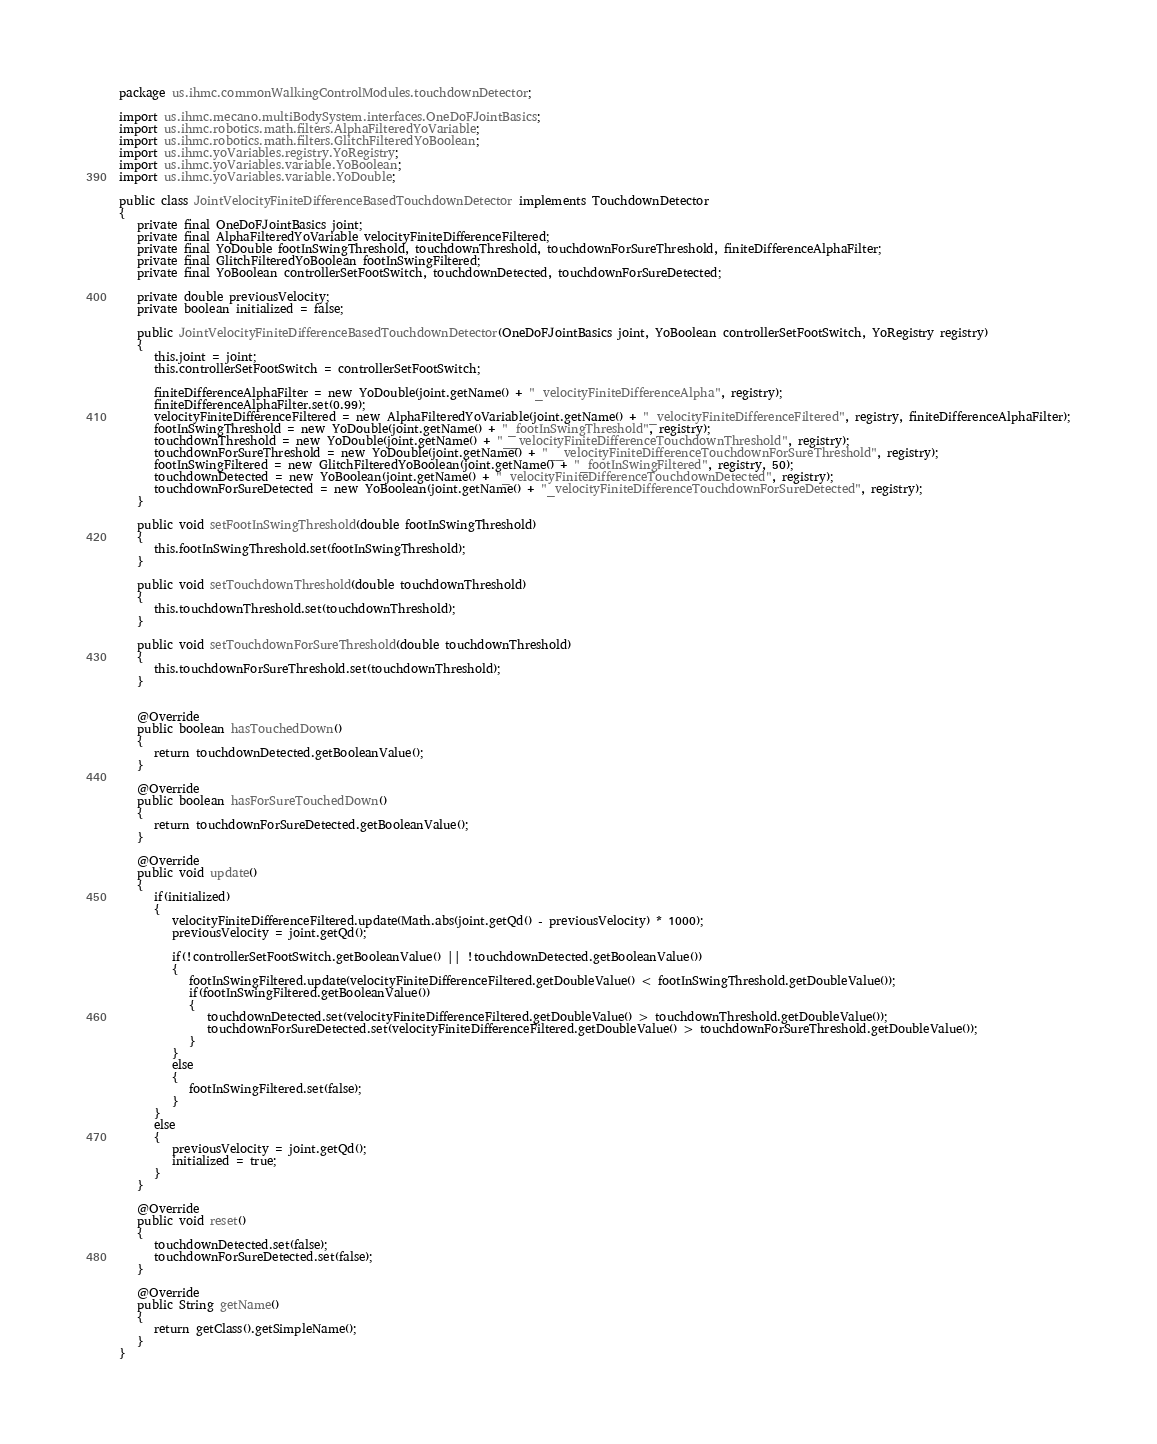<code> <loc_0><loc_0><loc_500><loc_500><_Java_>package us.ihmc.commonWalkingControlModules.touchdownDetector;

import us.ihmc.mecano.multiBodySystem.interfaces.OneDoFJointBasics;
import us.ihmc.robotics.math.filters.AlphaFilteredYoVariable;
import us.ihmc.robotics.math.filters.GlitchFilteredYoBoolean;
import us.ihmc.yoVariables.registry.YoRegistry;
import us.ihmc.yoVariables.variable.YoBoolean;
import us.ihmc.yoVariables.variable.YoDouble;

public class JointVelocityFiniteDifferenceBasedTouchdownDetector implements TouchdownDetector
{
   private final OneDoFJointBasics joint;
   private final AlphaFilteredYoVariable velocityFiniteDifferenceFiltered;
   private final YoDouble footInSwingThreshold, touchdownThreshold, touchdownForSureThreshold, finiteDifferenceAlphaFilter;
   private final GlitchFilteredYoBoolean footInSwingFiltered;
   private final YoBoolean controllerSetFootSwitch, touchdownDetected, touchdownForSureDetected;

   private double previousVelocity;
   private boolean initialized = false;

   public JointVelocityFiniteDifferenceBasedTouchdownDetector(OneDoFJointBasics joint, YoBoolean controllerSetFootSwitch, YoRegistry registry)
   {
      this.joint = joint;
      this.controllerSetFootSwitch = controllerSetFootSwitch;

      finiteDifferenceAlphaFilter = new YoDouble(joint.getName() + "_velocityFiniteDifferenceAlpha", registry);
      finiteDifferenceAlphaFilter.set(0.99);
      velocityFiniteDifferenceFiltered = new AlphaFilteredYoVariable(joint.getName() + "_velocityFiniteDifferenceFiltered", registry, finiteDifferenceAlphaFilter);
      footInSwingThreshold = new YoDouble(joint.getName() + "_footInSwingThreshold", registry);
      touchdownThreshold = new YoDouble(joint.getName() + "__velocityFiniteDifferenceTouchdownThreshold", registry);
      touchdownForSureThreshold = new YoDouble(joint.getName() + "__velocityFiniteDifferenceTouchdownForSureThreshold", registry);
      footInSwingFiltered = new GlitchFilteredYoBoolean(joint.getName() + "_footInSwingFiltered", registry, 50);
      touchdownDetected = new YoBoolean(joint.getName() + "_velocityFiniteDifferenceTouchdownDetected", registry);
      touchdownForSureDetected = new YoBoolean(joint.getName() + "_velocityFiniteDifferenceTouchdownForSureDetected", registry);
   }

   public void setFootInSwingThreshold(double footInSwingThreshold)
   {
      this.footInSwingThreshold.set(footInSwingThreshold);
   }

   public void setTouchdownThreshold(double touchdownThreshold)
   {
      this.touchdownThreshold.set(touchdownThreshold);
   }

   public void setTouchdownForSureThreshold(double touchdownThreshold)
   {
      this.touchdownForSureThreshold.set(touchdownThreshold);
   }


   @Override
   public boolean hasTouchedDown()
   {
      return touchdownDetected.getBooleanValue();
   }

   @Override
   public boolean hasForSureTouchedDown()
   {
      return touchdownForSureDetected.getBooleanValue();
   }

   @Override
   public void update()
   {
      if(initialized)
      {
         velocityFiniteDifferenceFiltered.update(Math.abs(joint.getQd() - previousVelocity) * 1000);
         previousVelocity = joint.getQd();

         if(!controllerSetFootSwitch.getBooleanValue() || !touchdownDetected.getBooleanValue())
         {
            footInSwingFiltered.update(velocityFiniteDifferenceFiltered.getDoubleValue() < footInSwingThreshold.getDoubleValue());
            if(footInSwingFiltered.getBooleanValue())
            {
               touchdownDetected.set(velocityFiniteDifferenceFiltered.getDoubleValue() > touchdownThreshold.getDoubleValue());
               touchdownForSureDetected.set(velocityFiniteDifferenceFiltered.getDoubleValue() > touchdownForSureThreshold.getDoubleValue());
            }
         }
         else
         {
            footInSwingFiltered.set(false);
         }
      }
      else
      {
         previousVelocity = joint.getQd();
         initialized = true;
      }
   }

   @Override
   public void reset()
   {
      touchdownDetected.set(false);
      touchdownForSureDetected.set(false);
   }

   @Override
   public String getName()
   {
      return getClass().getSimpleName();
   }
}
</code> 